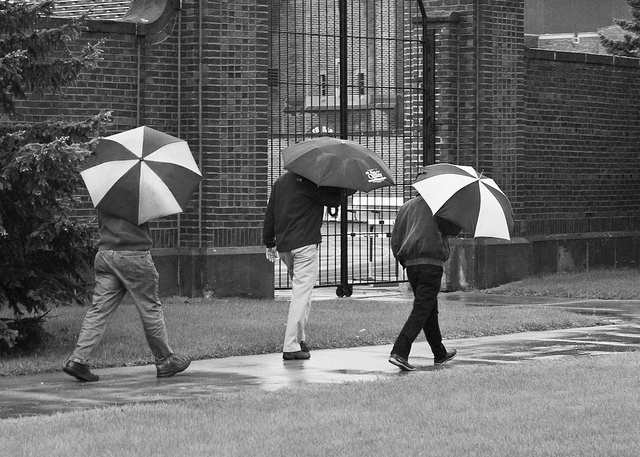Describe the objects in this image and their specific colors. I can see people in darkgray, gray, black, and lightgray tones, umbrella in darkgray, lightgray, gray, and black tones, people in darkgray, black, lightgray, and gray tones, people in darkgray, black, gray, and lightgray tones, and umbrella in darkgray, white, gray, and black tones in this image. 